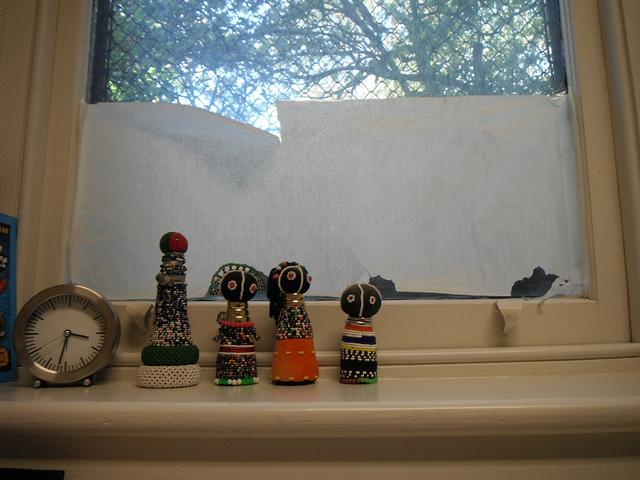Where is the clock?
Short answer required. Left. What is seen outside the window?
Give a very brief answer. Trees. How many tiers are on the cake?
Answer briefly. 0. What is in the window?
Answer briefly. Paper. How many objects is there?
Concise answer only. 5. 